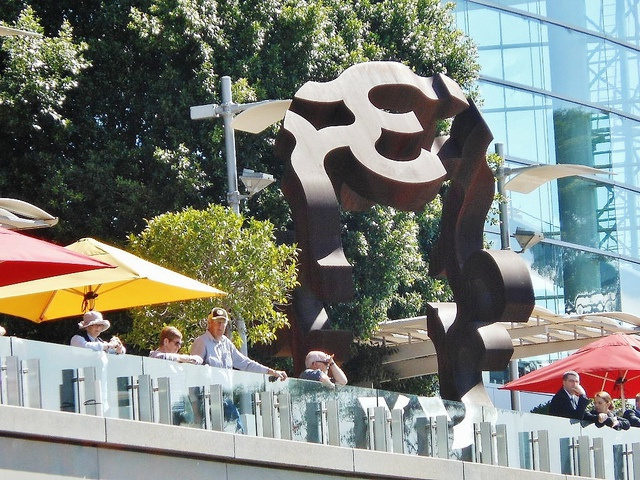Describe the objects in this image and their specific colors. I can see umbrella in black, gold, beige, orange, and khaki tones, umbrella in black, lightpink, brown, and salmon tones, umbrella in black, pink, brown, lightpink, and maroon tones, people in black, darkgray, lightgray, and gray tones, and umbrella in black, darkgray, tan, and lightgray tones in this image. 